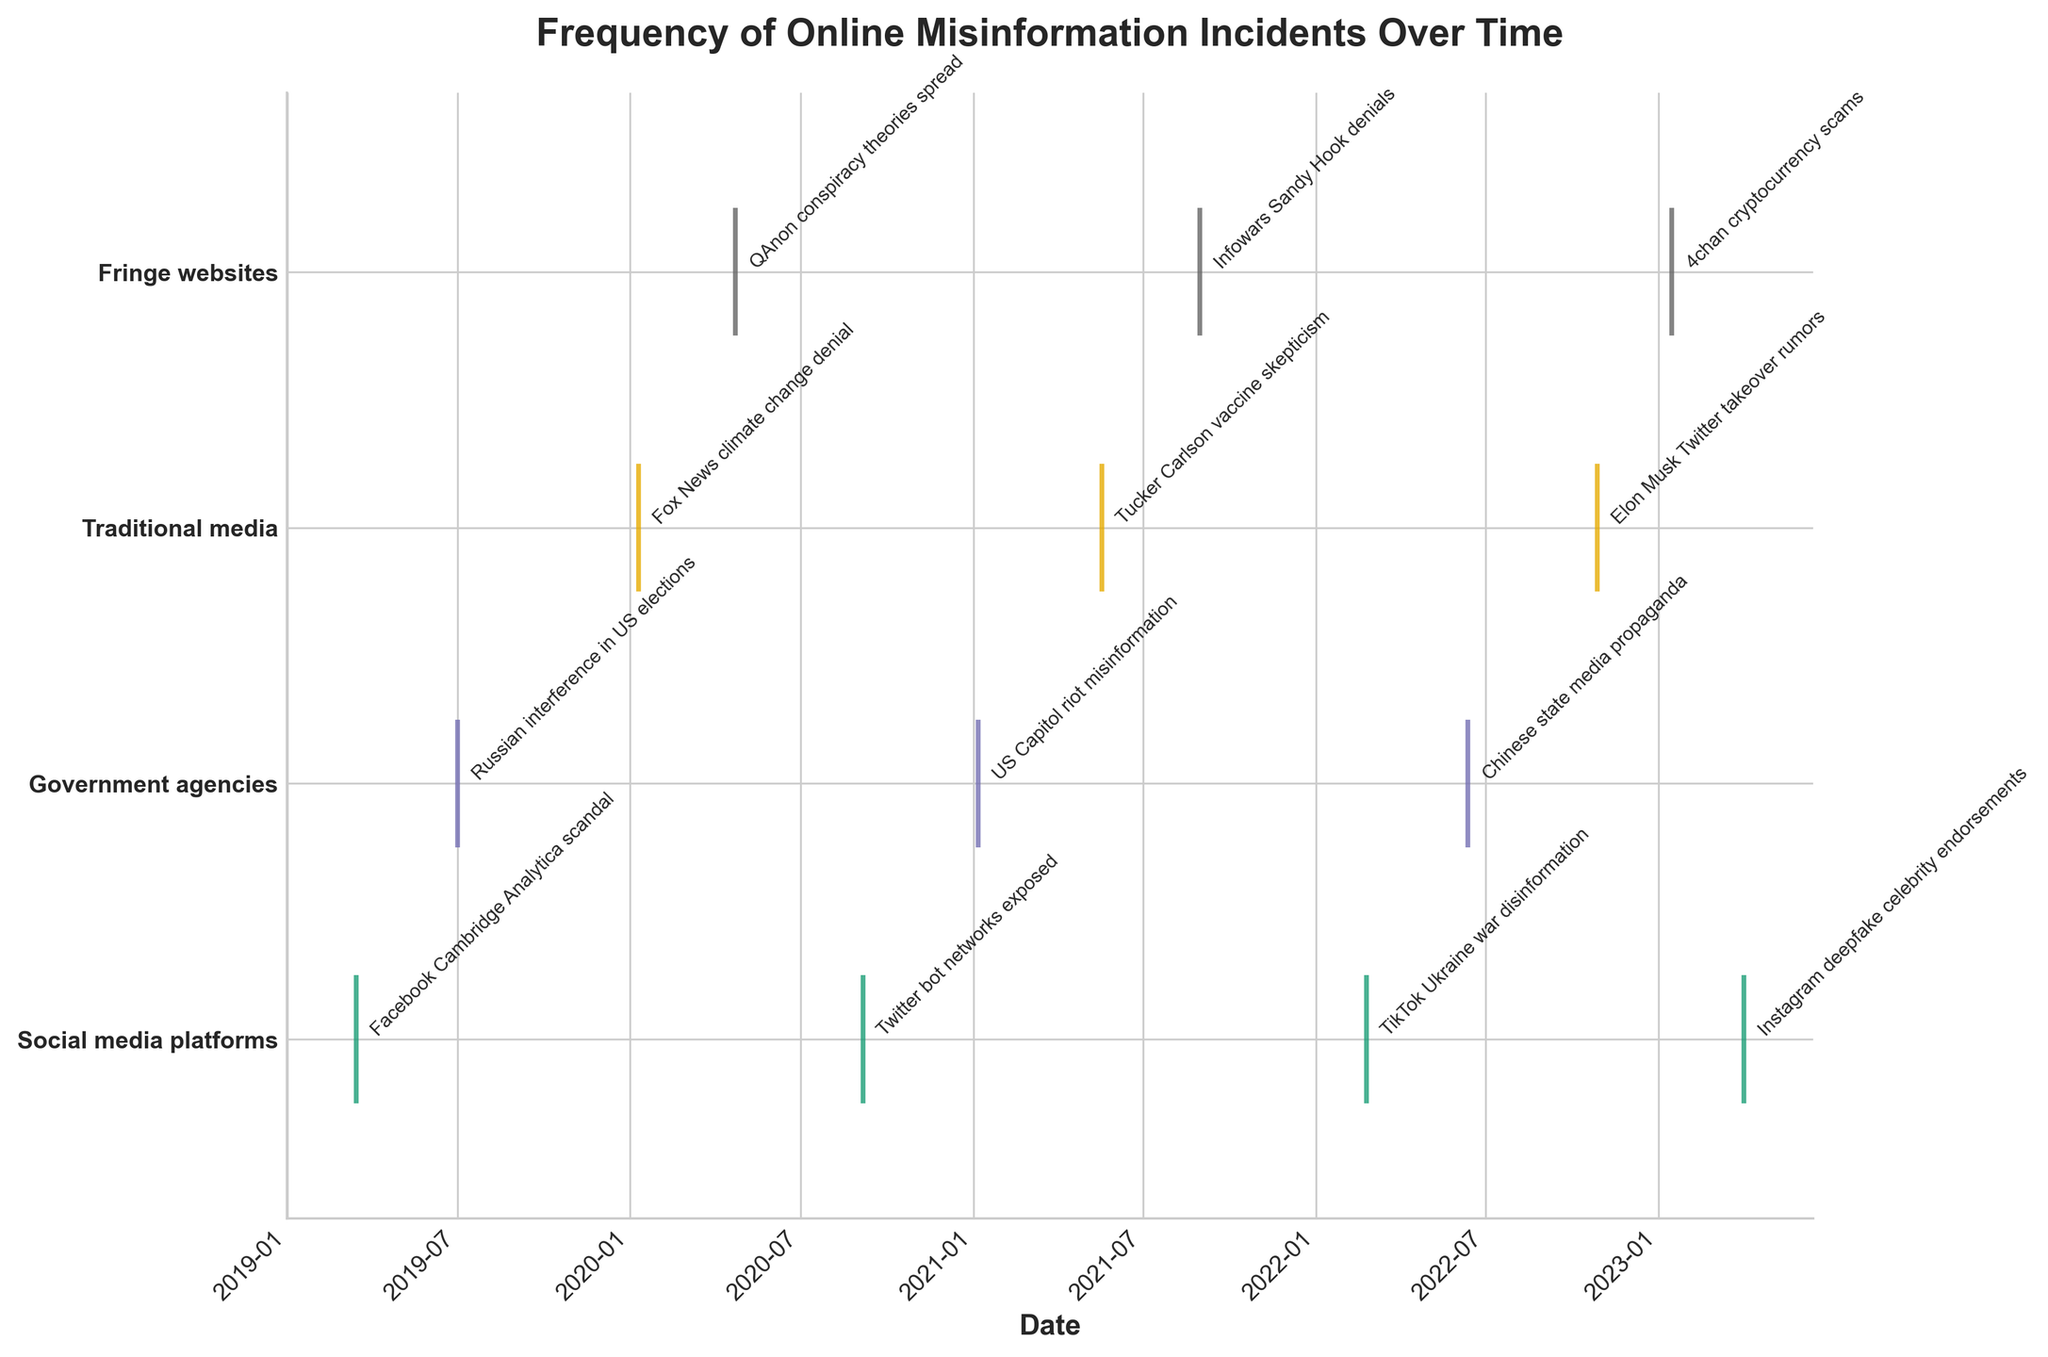Can you describe the title of the figure? The title is right above the plot and specifies what the figure is about. It reads "Frequency of Online Misinformation Incidents Over Time."
Answer: Frequency of Online Misinformation Incidents Over Time Which source type had an incident on 2021-05-18? By looking at the date 2021-05-18 and tracking the corresponding y-tick label, the label points to "Traditional media."
Answer: Traditional media How many total incidents are reported in the figure? Count all the annotated events in the plot from each category. There are a total of 13 incidents marked on the plot.
Answer: 13 Which source type shows the first incident? By checking the earliest date on the x-axis and following it to the corresponding y-tick label, the first incident is marked on 2019-03-15 at "Social media platforms."
Answer: Social media platforms What is the interval between the first incident and the second incident? The first incident happened on 2019-03-15 and the second on 2019-07-01. Calculate the difference between these dates, which is a bit more than 3 months.
Answer: Approximately 3.5 months Which source type had the most recent misinformation incident? Check the latest date on the x-axis and find the corresponding y-tick label. The most recent incident occurred on 2023-04-02, associated with "Social media platforms."
Answer: Social media platforms How many incidents are associated with Government agencies? Count the total number of events placed at the y-tick labeled "Government agencies." There are 3 incidents recorded in this category.
Answer: 3 Compare the number of incidents from Social media platforms versus Fringe websites. Which has more? Count the events plotted at the y-tick levels for "Social media platforms" and "Fringe websites." Social media platforms have 4 incidents, whereas Fringe websites have 3.
Answer: Social media platforms Was there any misinformation incident from Traditional media in the year 2022? Check the dates associated with Traditional media category to find if any event falls in the year 2022. One event is listed on 2022-10-28.
Answer: Yes Which source type shows a higher density of incidents in 2021 compared to 2020? Look at the number and spread of events for each source type in the years 2020 and 2021. "Government agencies" and "Traditional media" both show increased activity in 2021 compared to 2020.
Answer: Government agencies and Traditional media 